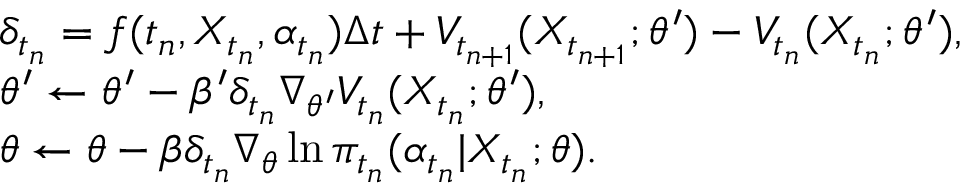<formula> <loc_0><loc_0><loc_500><loc_500>\begin{array} { r l } & { \delta _ { t _ { n } } = f ( t _ { n } , X _ { t _ { n } } , \alpha _ { t _ { n } } ) \Delta t + V _ { t _ { n + 1 } } ( X _ { t _ { n + 1 } } ; \theta ^ { \prime } ) - V _ { t _ { n } } ( X _ { t _ { n } } ; \theta ^ { \prime } ) , } \\ & { \theta ^ { \prime } \leftarrow \theta ^ { \prime } - \beta ^ { \prime } \delta _ { t _ { n } } \nabla _ { \theta ^ { \prime } } V _ { t _ { n } } ( X _ { t _ { n } } ; \theta ^ { \prime } ) , } \\ & { \theta \leftarrow \theta - \beta \delta _ { t _ { n } } \nabla _ { \theta } \ln \pi _ { t _ { n } } ( \alpha _ { t _ { n } } | X _ { t _ { n } } ; \theta ) . } \end{array}</formula> 